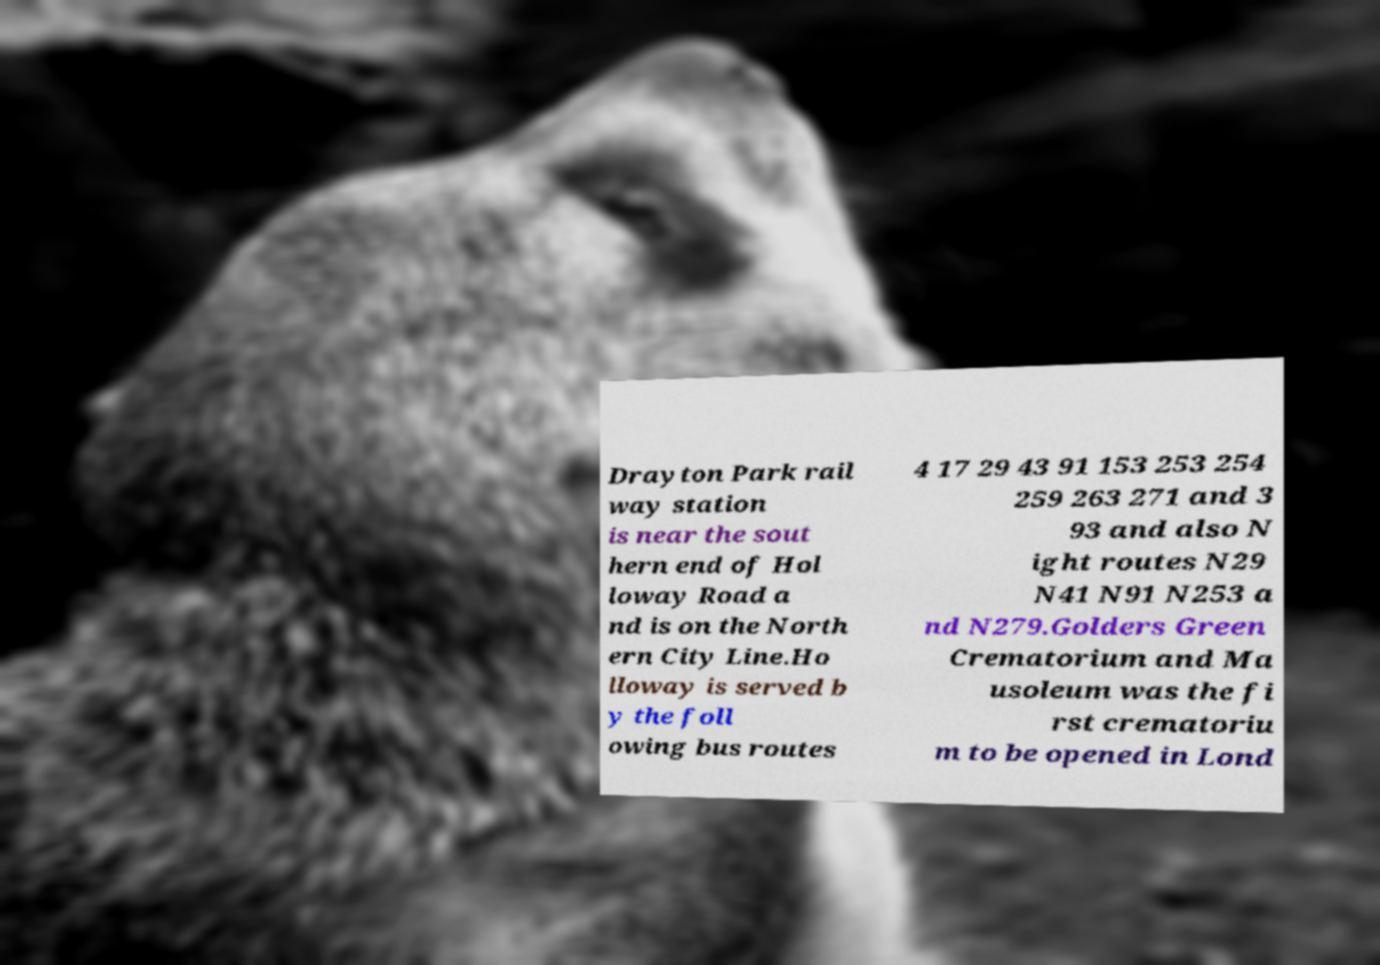Can you read and provide the text displayed in the image?This photo seems to have some interesting text. Can you extract and type it out for me? Drayton Park rail way station is near the sout hern end of Hol loway Road a nd is on the North ern City Line.Ho lloway is served b y the foll owing bus routes 4 17 29 43 91 153 253 254 259 263 271 and 3 93 and also N ight routes N29 N41 N91 N253 a nd N279.Golders Green Crematorium and Ma usoleum was the fi rst crematoriu m to be opened in Lond 